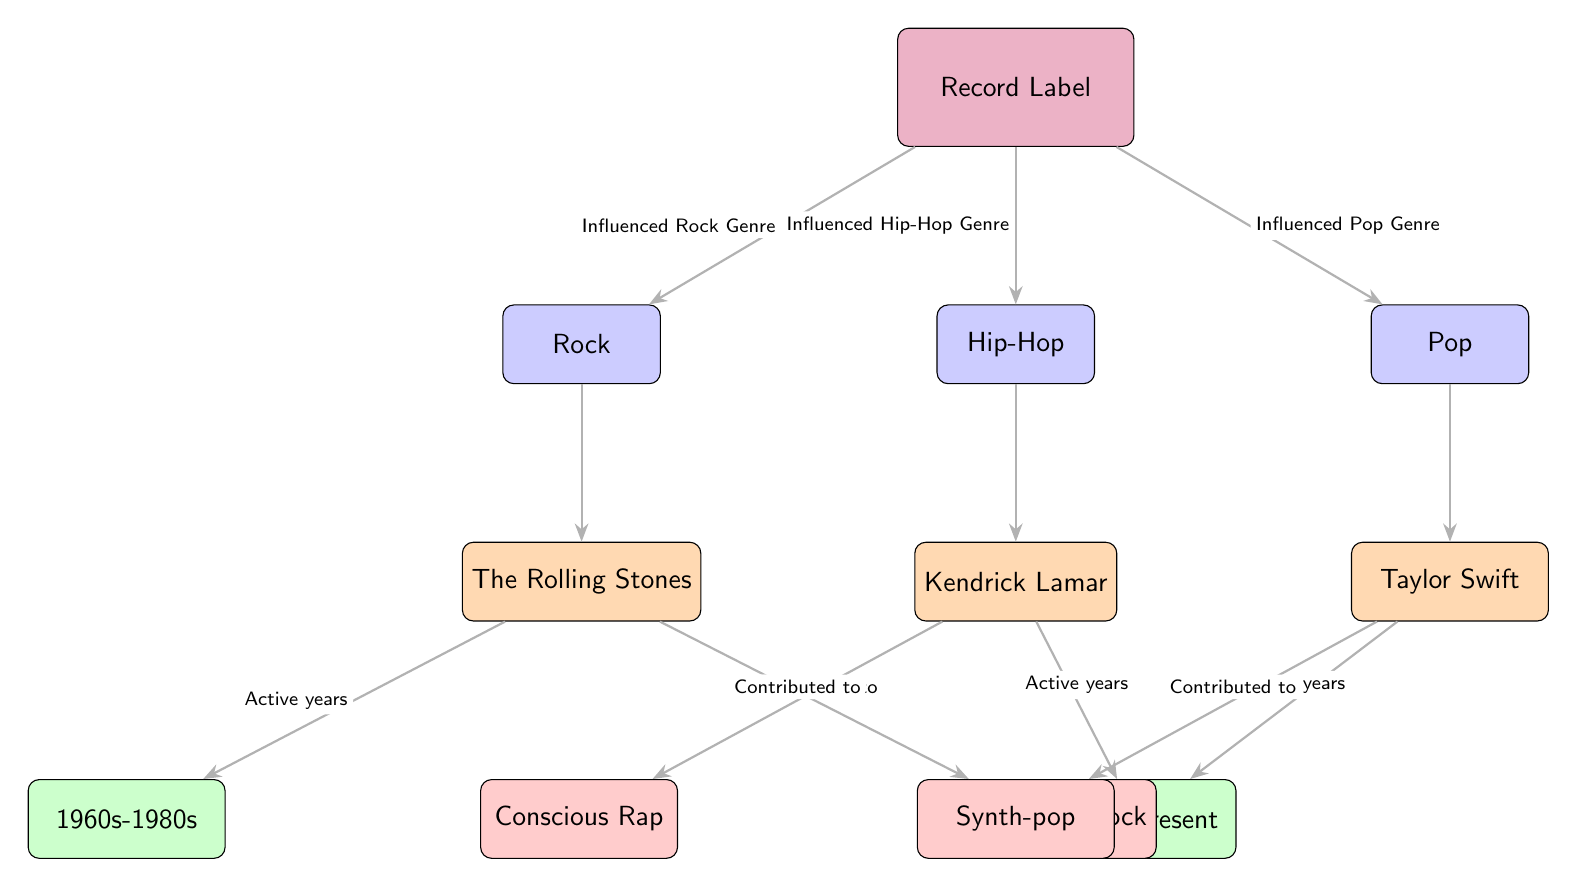What genres are influenced by the record label? The diagram clearly shows that the record label influences three genres: Rock, Hip-Hop, and Pop. These genres are indicated by the nodes directly connected to the label node.
Answer: Rock, Hip-Hop, Pop Who is associated with the Rock genre? The diagram has a direct connection from the Rock node to the artist node labeled "The Rolling Stones," indicating their association with the genre.
Answer: The Rolling Stones What subgenre is The Rolling Stones associated with? The edge connecting "The Rolling Stones" to the subgenre node indicates "Psychedelic Rock," which shows their contribution to that specific subgenre.
Answer: Psychedelic Rock During which era was Kendrick Lamar active? The edge connecting the artist node "Kendrick Lamar" to the era node shows "2000s-Present," indicating the time frame of his activity.
Answer: 2000s-Present How many artists are linked to subgenres in the diagram? The diagram shows that there are three artists linked to three different subgenres: The Rolling Stones to Psychedelic Rock, Kendrick Lamar to Conscious Rap, and Taylor Swift to Synth-pop, totaling three artists.
Answer: 3 Which artist contributed to the Conscious Rap subgenre? The diagram connects the artist node "Kendrick Lamar" directly to the subgenre node labeled "Conscious Rap," confirming his contribution to this specific subgenre.
Answer: Kendrick Lamar What is the time frame of active years for The Rolling Stones? The edge from "The Rolling Stones" connects to the era node labeled "1960s-1980s," detailing the active years for this artist.
Answer: 1960s-1980s What is the relationship between the label and the Pop genre? The diagram illustrates a direct edge between the record label and the Pop genre node, indicating that the label influences the Pop genre.
Answer: Influenced Pop Genre Which artist is affiliated with the Synth-pop subgenre? The diagram shows a direct link between the artist node "Taylor Swift" and the subgenre node labeled "Synth-pop," establishing Taylor Swift's affiliation with this subgenre.
Answer: Taylor Swift 